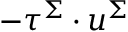Convert formula to latex. <formula><loc_0><loc_0><loc_500><loc_500>- \tau ^ { \Sigma } \cdot u ^ { \Sigma }</formula> 